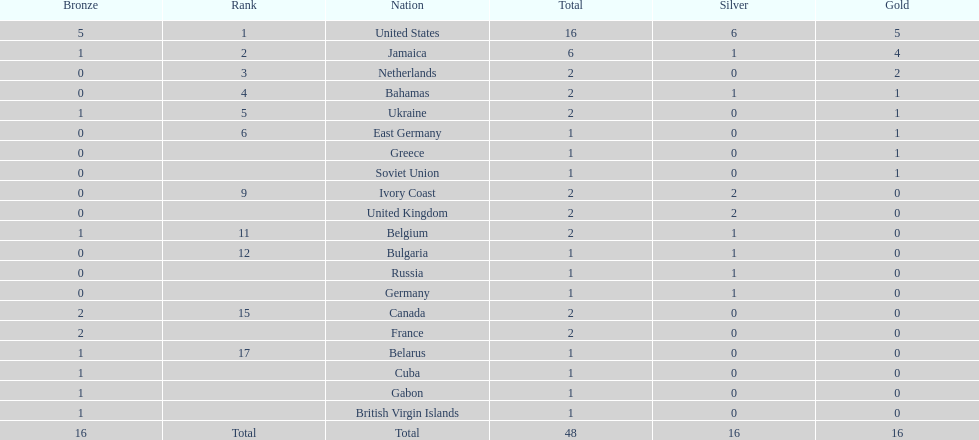How many nations won no gold medals? 12. 